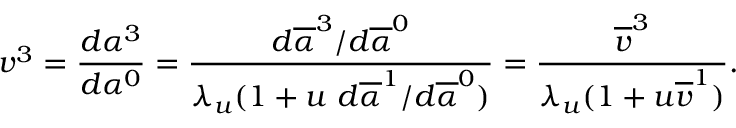Convert formula to latex. <formula><loc_0><loc_0><loc_500><loc_500>v ^ { 3 } = \frac { d \alpha ^ { 3 } } { d \alpha ^ { 0 } } = \frac { d \overline { \alpha } ^ { 3 } / d \overline { \alpha } ^ { 0 } } { \lambda _ { u } ( 1 + u d \overline { \alpha } ^ { 1 } / d \overline { \alpha } ^ { 0 } ) } = \frac { \overline { v } ^ { 3 } } { \lambda _ { u } ( 1 + u \overline { v } ^ { 1 } ) } .</formula> 